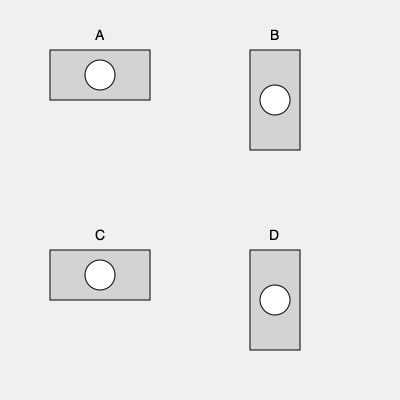Which of the breathalyzer devices shown above (A, B, C, or D) represents the correct orientation for conducting a breath test on a standing subject, assuming the officer is holding the device at chest level? To determine the correct orientation of the breathalyzer device, we need to consider the following steps:

1. Understand the basic structure of a breathalyzer:
   - It typically has a rectangular body with a mouthpiece for the subject to blow into.

2. Consider the officer's position:
   - The officer is standing and holding the device at chest level.

3. Consider the subject's position:
   - The subject is also standing, facing the officer.

4. Analyze each option:
   A: Horizontal orientation with mouthpiece facing left.
   B: Vertical orientation with mouthpiece facing up.
   C: Horizontal orientation with mouthpiece facing right.
   D: Vertical orientation with mouthpiece facing down.

5. Determine the correct orientation:
   - The mouthpiece should be easily accessible to the subject's mouth.
   - Given that both the officer and subject are standing, the device should be held horizontally.
   - The mouthpiece should face the subject (to the right from the officer's perspective).

6. Compare with given options:
   - Option C matches this description: horizontal orientation with mouthpiece facing right.

Therefore, the correct orientation for conducting a breath test on a standing subject, with the officer holding the device at chest level, is represented by option C.
Answer: C 